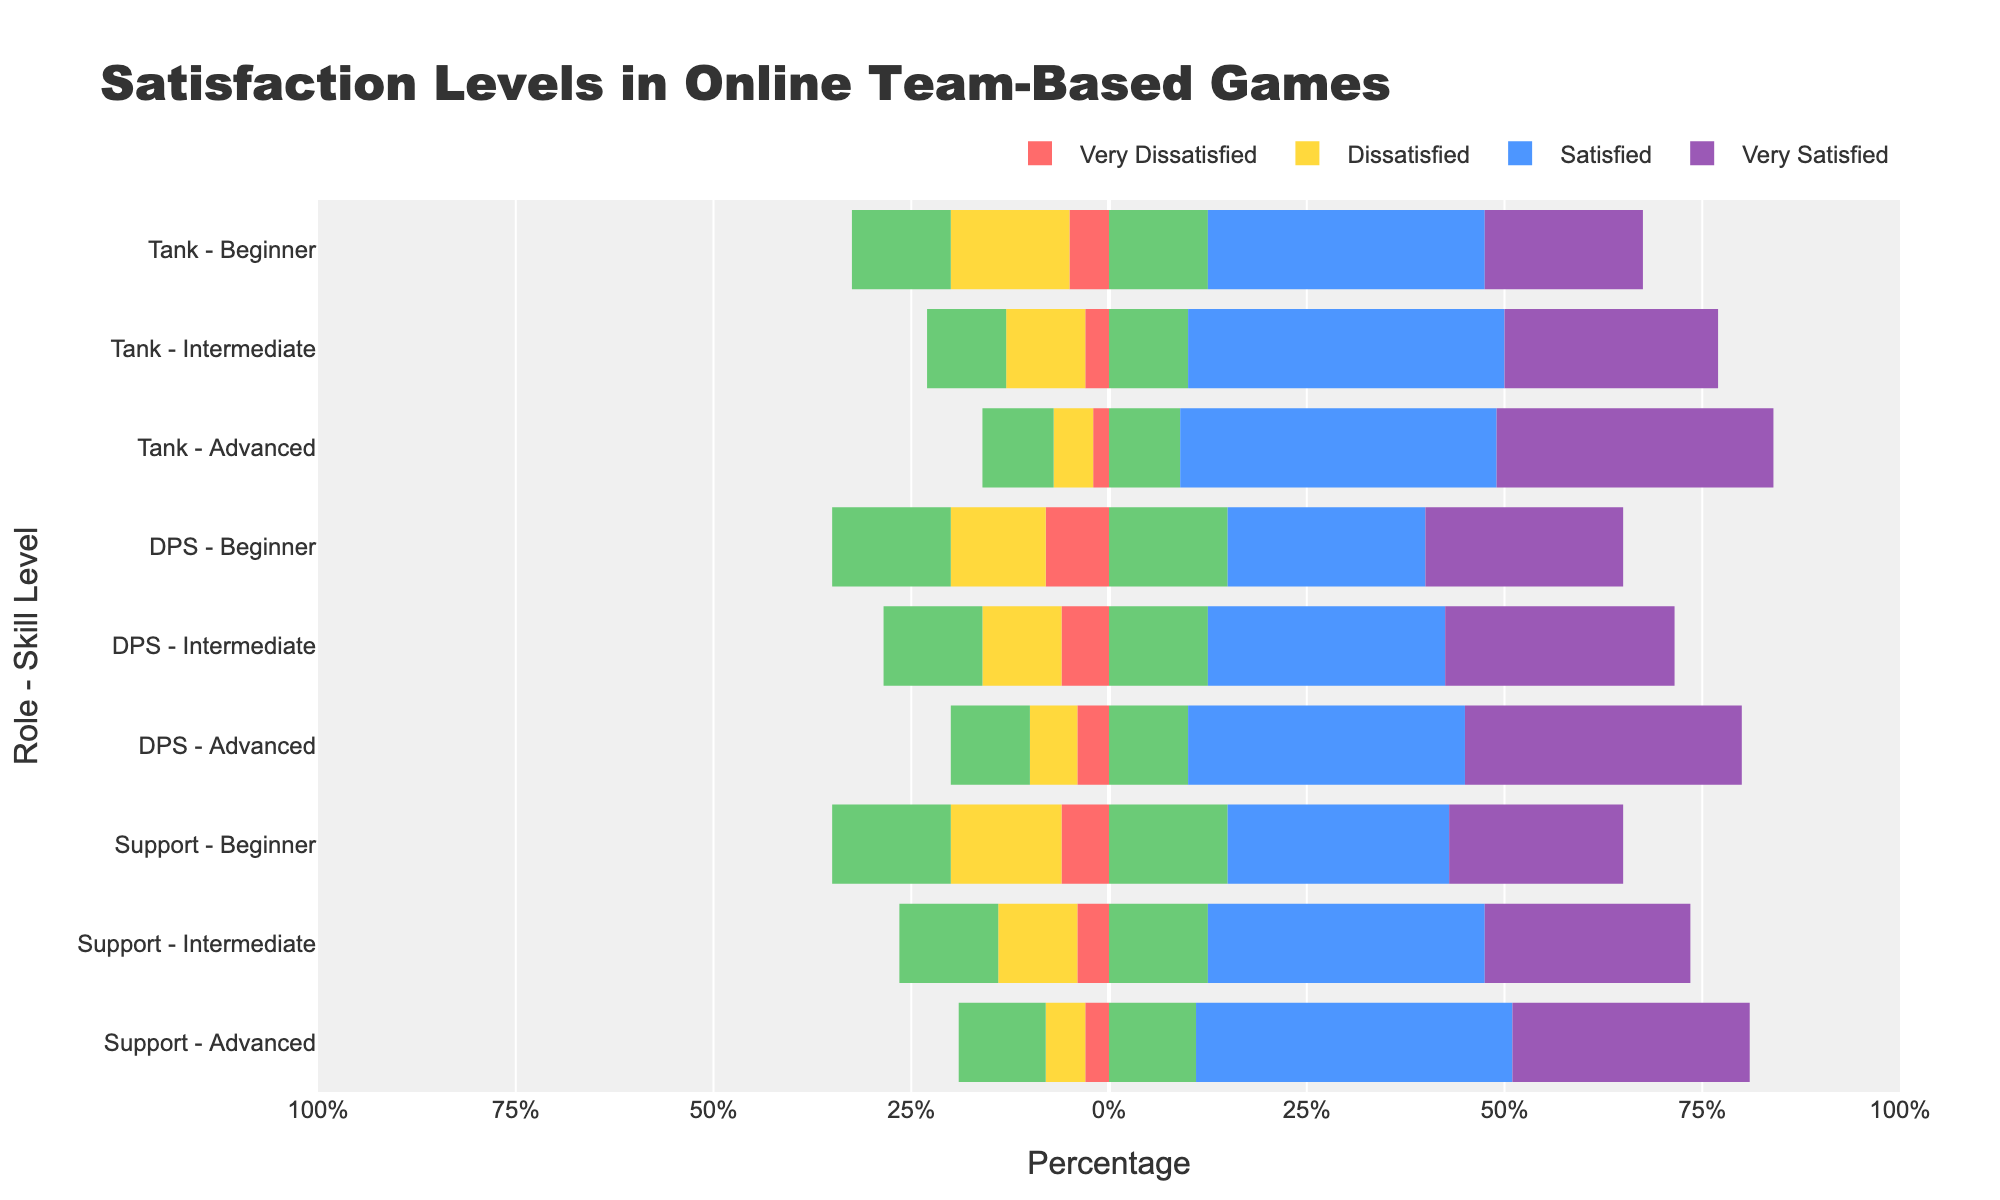what is the percentage of satisfied and very satisfied players at the beginner level for Tanks? For the beginner level of Tanks, the Satisfied percentage is 35% and the Very Satisfied percentage is 20%. Summing these, 35 + 20 = 55%.
Answer: 55% Which role and skill level has the highest percentage of very satisfied players? Look for the highest value in the Very Satisfied columns across all roles and skill levels. The Advanced level for the Tank role has 35%, which is the highest.
Answer: Tank - Advanced Compare the percentage of dissatisfied players between DPS - Intermediate and Support - Intermediate. Which is higher? For DPS - Intermediate, Dissatisfied is 10%. For Support - Intermediate, it is also 10%. Therefore, they are equal.
Answer: Equal How does the satisfaction level of Satisfied for Support at the Advanced level compare to that for Support at the Beginner level? For Support - Advanced, the Satisfied percentage is 40%. For Support - Beginner, it is 28%. Hence, 40% is greater than 28%.
Answer: Higher What is the neutral percentage for DPS players at the beginner and advanced levels combined? For DPS - Beginner, Neutral is 30%. For DPS - Advanced, it is 20%. The sum is 30 + 20 = 50%.
Answer: 50% How does the percentage of very dissatisfied players for Tanks at the beginner level compare to DPS at the same level? For Tank - Beginner, Very Dissatisfied is 5%. For DPS - Beginner, it is 8%. Therefore, 5% is less than 8%.
Answer: Lower Which role has the largest percentage of neutral players at the intermediate level? Compare the Neutral percentages for the Intermediate skill level across all roles. The percentages are 20% for Tank, 25% for DPS, and 25% for Support. The highest, in this case, is 25%, shared by DPS and Support.
Answer: DPS and Support What is the difference in percentage between dissatisfied players for Tank - Advanced and DPS - Advanced? Tank - Advanced has 5% Dissatisfied, and DPS - Advanced has 6% Dissatisfied. The difference is 6% - 5% = 1%.
Answer: 1% What percentage of Tank players are either very dissatisfied or dissatisfied at the intermediate level? Add the percentages of Very Dissatisfied (3%) and Dissatisfied (10%) for Tank - Intermediate. The sum is 3 + 10 = 13%.
Answer: 13% 